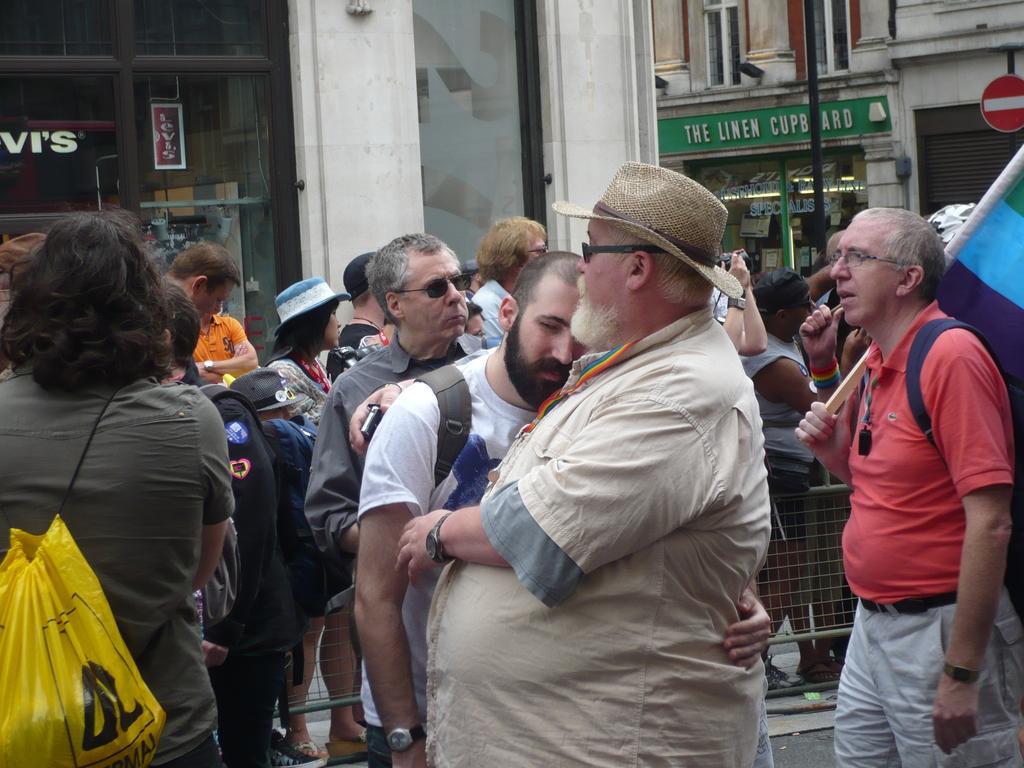How would you summarize this image in a sentence or two? In this image there are group of people standing on the street , a person holding a flag , and in the background there are buildings with name boards , pole. 